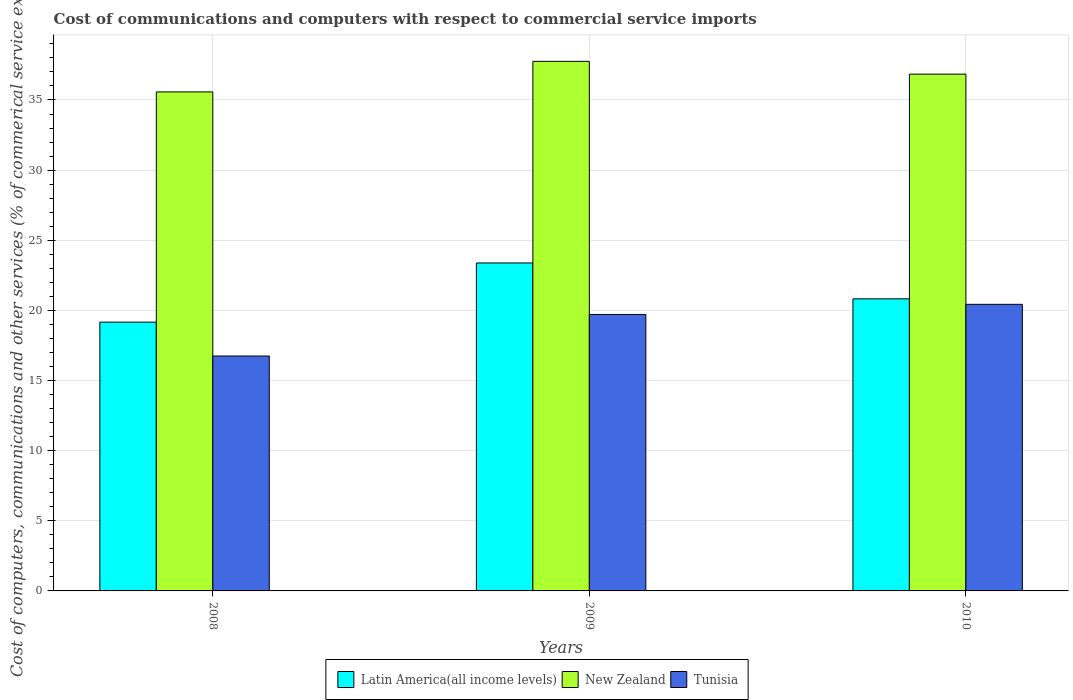Are the number of bars on each tick of the X-axis equal?
Your answer should be compact. Yes. How many bars are there on the 2nd tick from the left?
Give a very brief answer. 3. How many bars are there on the 2nd tick from the right?
Provide a succinct answer. 3. In how many cases, is the number of bars for a given year not equal to the number of legend labels?
Make the answer very short. 0. What is the cost of communications and computers in New Zealand in 2008?
Keep it short and to the point. 35.58. Across all years, what is the maximum cost of communications and computers in Tunisia?
Ensure brevity in your answer.  20.43. Across all years, what is the minimum cost of communications and computers in Tunisia?
Ensure brevity in your answer.  16.75. In which year was the cost of communications and computers in Tunisia maximum?
Ensure brevity in your answer.  2010. In which year was the cost of communications and computers in Tunisia minimum?
Offer a very short reply. 2008. What is the total cost of communications and computers in Tunisia in the graph?
Provide a short and direct response. 56.89. What is the difference between the cost of communications and computers in New Zealand in 2008 and that in 2009?
Make the answer very short. -2.18. What is the difference between the cost of communications and computers in Tunisia in 2008 and the cost of communications and computers in New Zealand in 2009?
Make the answer very short. -21.01. What is the average cost of communications and computers in New Zealand per year?
Make the answer very short. 36.72. In the year 2008, what is the difference between the cost of communications and computers in Latin America(all income levels) and cost of communications and computers in Tunisia?
Your answer should be compact. 2.42. What is the ratio of the cost of communications and computers in New Zealand in 2008 to that in 2009?
Provide a succinct answer. 0.94. Is the difference between the cost of communications and computers in Latin America(all income levels) in 2008 and 2010 greater than the difference between the cost of communications and computers in Tunisia in 2008 and 2010?
Your answer should be compact. Yes. What is the difference between the highest and the second highest cost of communications and computers in Latin America(all income levels)?
Provide a succinct answer. 2.56. What is the difference between the highest and the lowest cost of communications and computers in Latin America(all income levels)?
Offer a very short reply. 4.22. What does the 2nd bar from the left in 2010 represents?
Give a very brief answer. New Zealand. What does the 2nd bar from the right in 2008 represents?
Make the answer very short. New Zealand. Is it the case that in every year, the sum of the cost of communications and computers in Tunisia and cost of communications and computers in Latin America(all income levels) is greater than the cost of communications and computers in New Zealand?
Provide a succinct answer. Yes. Are all the bars in the graph horizontal?
Make the answer very short. No. How many years are there in the graph?
Your answer should be compact. 3. What is the difference between two consecutive major ticks on the Y-axis?
Provide a short and direct response. 5. Does the graph contain any zero values?
Make the answer very short. No. Where does the legend appear in the graph?
Make the answer very short. Bottom center. How many legend labels are there?
Offer a very short reply. 3. How are the legend labels stacked?
Offer a very short reply. Horizontal. What is the title of the graph?
Your response must be concise. Cost of communications and computers with respect to commercial service imports. Does "Bhutan" appear as one of the legend labels in the graph?
Make the answer very short. No. What is the label or title of the Y-axis?
Give a very brief answer. Cost of computers, communications and other services (% of commerical service exports). What is the Cost of computers, communications and other services (% of commerical service exports) of Latin America(all income levels) in 2008?
Ensure brevity in your answer.  19.16. What is the Cost of computers, communications and other services (% of commerical service exports) in New Zealand in 2008?
Provide a short and direct response. 35.58. What is the Cost of computers, communications and other services (% of commerical service exports) in Tunisia in 2008?
Your response must be concise. 16.75. What is the Cost of computers, communications and other services (% of commerical service exports) in Latin America(all income levels) in 2009?
Your response must be concise. 23.38. What is the Cost of computers, communications and other services (% of commerical service exports) of New Zealand in 2009?
Provide a succinct answer. 37.75. What is the Cost of computers, communications and other services (% of commerical service exports) in Tunisia in 2009?
Your answer should be compact. 19.71. What is the Cost of computers, communications and other services (% of commerical service exports) in Latin America(all income levels) in 2010?
Ensure brevity in your answer.  20.82. What is the Cost of computers, communications and other services (% of commerical service exports) in New Zealand in 2010?
Your answer should be very brief. 36.84. What is the Cost of computers, communications and other services (% of commerical service exports) of Tunisia in 2010?
Ensure brevity in your answer.  20.43. Across all years, what is the maximum Cost of computers, communications and other services (% of commerical service exports) in Latin America(all income levels)?
Your answer should be compact. 23.38. Across all years, what is the maximum Cost of computers, communications and other services (% of commerical service exports) in New Zealand?
Offer a very short reply. 37.75. Across all years, what is the maximum Cost of computers, communications and other services (% of commerical service exports) in Tunisia?
Keep it short and to the point. 20.43. Across all years, what is the minimum Cost of computers, communications and other services (% of commerical service exports) in Latin America(all income levels)?
Provide a short and direct response. 19.16. Across all years, what is the minimum Cost of computers, communications and other services (% of commerical service exports) in New Zealand?
Keep it short and to the point. 35.58. Across all years, what is the minimum Cost of computers, communications and other services (% of commerical service exports) in Tunisia?
Your answer should be very brief. 16.75. What is the total Cost of computers, communications and other services (% of commerical service exports) of Latin America(all income levels) in the graph?
Offer a terse response. 63.37. What is the total Cost of computers, communications and other services (% of commerical service exports) of New Zealand in the graph?
Ensure brevity in your answer.  110.17. What is the total Cost of computers, communications and other services (% of commerical service exports) of Tunisia in the graph?
Offer a very short reply. 56.89. What is the difference between the Cost of computers, communications and other services (% of commerical service exports) in Latin America(all income levels) in 2008 and that in 2009?
Provide a short and direct response. -4.22. What is the difference between the Cost of computers, communications and other services (% of commerical service exports) in New Zealand in 2008 and that in 2009?
Give a very brief answer. -2.18. What is the difference between the Cost of computers, communications and other services (% of commerical service exports) in Tunisia in 2008 and that in 2009?
Keep it short and to the point. -2.96. What is the difference between the Cost of computers, communications and other services (% of commerical service exports) in Latin America(all income levels) in 2008 and that in 2010?
Make the answer very short. -1.66. What is the difference between the Cost of computers, communications and other services (% of commerical service exports) of New Zealand in 2008 and that in 2010?
Offer a terse response. -1.27. What is the difference between the Cost of computers, communications and other services (% of commerical service exports) in Tunisia in 2008 and that in 2010?
Ensure brevity in your answer.  -3.69. What is the difference between the Cost of computers, communications and other services (% of commerical service exports) in Latin America(all income levels) in 2009 and that in 2010?
Give a very brief answer. 2.56. What is the difference between the Cost of computers, communications and other services (% of commerical service exports) of New Zealand in 2009 and that in 2010?
Your answer should be very brief. 0.91. What is the difference between the Cost of computers, communications and other services (% of commerical service exports) in Tunisia in 2009 and that in 2010?
Offer a very short reply. -0.72. What is the difference between the Cost of computers, communications and other services (% of commerical service exports) in Latin America(all income levels) in 2008 and the Cost of computers, communications and other services (% of commerical service exports) in New Zealand in 2009?
Make the answer very short. -18.59. What is the difference between the Cost of computers, communications and other services (% of commerical service exports) in Latin America(all income levels) in 2008 and the Cost of computers, communications and other services (% of commerical service exports) in Tunisia in 2009?
Your answer should be very brief. -0.55. What is the difference between the Cost of computers, communications and other services (% of commerical service exports) in New Zealand in 2008 and the Cost of computers, communications and other services (% of commerical service exports) in Tunisia in 2009?
Keep it short and to the point. 15.87. What is the difference between the Cost of computers, communications and other services (% of commerical service exports) in Latin America(all income levels) in 2008 and the Cost of computers, communications and other services (% of commerical service exports) in New Zealand in 2010?
Keep it short and to the point. -17.68. What is the difference between the Cost of computers, communications and other services (% of commerical service exports) of Latin America(all income levels) in 2008 and the Cost of computers, communications and other services (% of commerical service exports) of Tunisia in 2010?
Make the answer very short. -1.27. What is the difference between the Cost of computers, communications and other services (% of commerical service exports) in New Zealand in 2008 and the Cost of computers, communications and other services (% of commerical service exports) in Tunisia in 2010?
Your response must be concise. 15.14. What is the difference between the Cost of computers, communications and other services (% of commerical service exports) in Latin America(all income levels) in 2009 and the Cost of computers, communications and other services (% of commerical service exports) in New Zealand in 2010?
Provide a succinct answer. -13.46. What is the difference between the Cost of computers, communications and other services (% of commerical service exports) of Latin America(all income levels) in 2009 and the Cost of computers, communications and other services (% of commerical service exports) of Tunisia in 2010?
Make the answer very short. 2.95. What is the difference between the Cost of computers, communications and other services (% of commerical service exports) of New Zealand in 2009 and the Cost of computers, communications and other services (% of commerical service exports) of Tunisia in 2010?
Provide a succinct answer. 17.32. What is the average Cost of computers, communications and other services (% of commerical service exports) of Latin America(all income levels) per year?
Offer a terse response. 21.12. What is the average Cost of computers, communications and other services (% of commerical service exports) of New Zealand per year?
Offer a terse response. 36.72. What is the average Cost of computers, communications and other services (% of commerical service exports) of Tunisia per year?
Give a very brief answer. 18.96. In the year 2008, what is the difference between the Cost of computers, communications and other services (% of commerical service exports) of Latin America(all income levels) and Cost of computers, communications and other services (% of commerical service exports) of New Zealand?
Give a very brief answer. -16.41. In the year 2008, what is the difference between the Cost of computers, communications and other services (% of commerical service exports) in Latin America(all income levels) and Cost of computers, communications and other services (% of commerical service exports) in Tunisia?
Give a very brief answer. 2.42. In the year 2008, what is the difference between the Cost of computers, communications and other services (% of commerical service exports) of New Zealand and Cost of computers, communications and other services (% of commerical service exports) of Tunisia?
Ensure brevity in your answer.  18.83. In the year 2009, what is the difference between the Cost of computers, communications and other services (% of commerical service exports) of Latin America(all income levels) and Cost of computers, communications and other services (% of commerical service exports) of New Zealand?
Your answer should be very brief. -14.37. In the year 2009, what is the difference between the Cost of computers, communications and other services (% of commerical service exports) in Latin America(all income levels) and Cost of computers, communications and other services (% of commerical service exports) in Tunisia?
Offer a terse response. 3.67. In the year 2009, what is the difference between the Cost of computers, communications and other services (% of commerical service exports) of New Zealand and Cost of computers, communications and other services (% of commerical service exports) of Tunisia?
Offer a very short reply. 18.04. In the year 2010, what is the difference between the Cost of computers, communications and other services (% of commerical service exports) in Latin America(all income levels) and Cost of computers, communications and other services (% of commerical service exports) in New Zealand?
Offer a very short reply. -16.02. In the year 2010, what is the difference between the Cost of computers, communications and other services (% of commerical service exports) in Latin America(all income levels) and Cost of computers, communications and other services (% of commerical service exports) in Tunisia?
Keep it short and to the point. 0.39. In the year 2010, what is the difference between the Cost of computers, communications and other services (% of commerical service exports) in New Zealand and Cost of computers, communications and other services (% of commerical service exports) in Tunisia?
Make the answer very short. 16.41. What is the ratio of the Cost of computers, communications and other services (% of commerical service exports) of Latin America(all income levels) in 2008 to that in 2009?
Your response must be concise. 0.82. What is the ratio of the Cost of computers, communications and other services (% of commerical service exports) of New Zealand in 2008 to that in 2009?
Provide a succinct answer. 0.94. What is the ratio of the Cost of computers, communications and other services (% of commerical service exports) in Tunisia in 2008 to that in 2009?
Ensure brevity in your answer.  0.85. What is the ratio of the Cost of computers, communications and other services (% of commerical service exports) of Latin America(all income levels) in 2008 to that in 2010?
Provide a succinct answer. 0.92. What is the ratio of the Cost of computers, communications and other services (% of commerical service exports) in New Zealand in 2008 to that in 2010?
Provide a succinct answer. 0.97. What is the ratio of the Cost of computers, communications and other services (% of commerical service exports) of Tunisia in 2008 to that in 2010?
Offer a very short reply. 0.82. What is the ratio of the Cost of computers, communications and other services (% of commerical service exports) of Latin America(all income levels) in 2009 to that in 2010?
Provide a short and direct response. 1.12. What is the ratio of the Cost of computers, communications and other services (% of commerical service exports) of New Zealand in 2009 to that in 2010?
Your response must be concise. 1.02. What is the ratio of the Cost of computers, communications and other services (% of commerical service exports) of Tunisia in 2009 to that in 2010?
Your answer should be very brief. 0.96. What is the difference between the highest and the second highest Cost of computers, communications and other services (% of commerical service exports) of Latin America(all income levels)?
Provide a succinct answer. 2.56. What is the difference between the highest and the second highest Cost of computers, communications and other services (% of commerical service exports) in New Zealand?
Provide a succinct answer. 0.91. What is the difference between the highest and the second highest Cost of computers, communications and other services (% of commerical service exports) in Tunisia?
Your answer should be very brief. 0.72. What is the difference between the highest and the lowest Cost of computers, communications and other services (% of commerical service exports) in Latin America(all income levels)?
Keep it short and to the point. 4.22. What is the difference between the highest and the lowest Cost of computers, communications and other services (% of commerical service exports) in New Zealand?
Your response must be concise. 2.18. What is the difference between the highest and the lowest Cost of computers, communications and other services (% of commerical service exports) of Tunisia?
Provide a succinct answer. 3.69. 